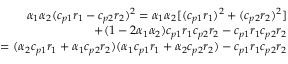Convert formula to latex. <formula><loc_0><loc_0><loc_500><loc_500>\begin{array} { r } { \alpha _ { 1 } \alpha _ { 2 } ( c _ { p 1 } r _ { 1 } - c _ { p 2 } r _ { 2 } ) ^ { 2 } = \alpha _ { 1 } \alpha _ { 2 } [ ( c _ { p 1 } r _ { 1 } ) ^ { 2 } + ( c _ { p 2 } r _ { 2 } ) ^ { 2 } ] } \\ { + ( 1 - 2 \alpha _ { 1 } \alpha _ { 2 } ) c _ { p 1 } r _ { 1 } c _ { p 2 } r _ { 2 } - c _ { p 1 } r _ { 1 } c _ { p 2 } r _ { 2 } } \\ { = ( \alpha _ { 2 } c _ { p 1 } r _ { 1 } + \alpha _ { 1 } c _ { p 2 } r _ { 2 } ) ( \alpha _ { 1 } c _ { p 1 } r _ { 1 } + \alpha _ { 2 } c _ { p 2 } r _ { 2 } ) - c _ { p 1 } r _ { 1 } c _ { p 2 } r _ { 2 } } \end{array}</formula> 